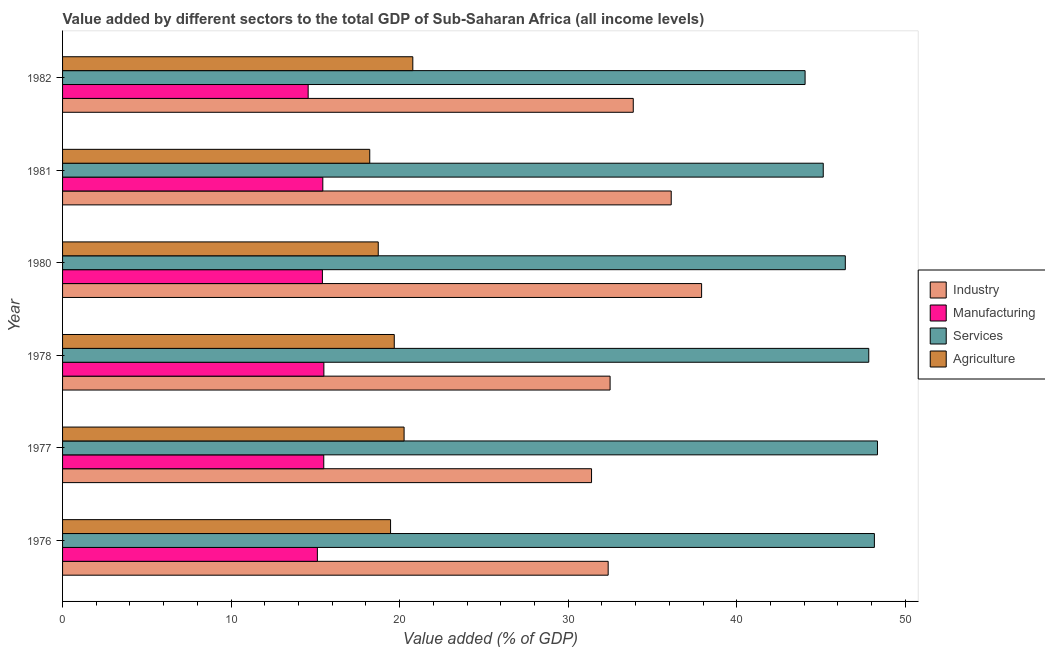How many different coloured bars are there?
Your answer should be very brief. 4. Are the number of bars per tick equal to the number of legend labels?
Keep it short and to the point. Yes. How many bars are there on the 3rd tick from the top?
Provide a succinct answer. 4. What is the label of the 6th group of bars from the top?
Your response must be concise. 1976. In how many cases, is the number of bars for a given year not equal to the number of legend labels?
Ensure brevity in your answer.  0. What is the value added by agricultural sector in 1981?
Your response must be concise. 18.23. Across all years, what is the maximum value added by manufacturing sector?
Your answer should be compact. 15.5. Across all years, what is the minimum value added by agricultural sector?
Provide a succinct answer. 18.23. In which year was the value added by services sector minimum?
Your answer should be compact. 1982. What is the total value added by services sector in the graph?
Provide a succinct answer. 279.98. What is the difference between the value added by services sector in 1981 and that in 1982?
Your response must be concise. 1.08. What is the difference between the value added by manufacturing sector in 1977 and the value added by industrial sector in 1980?
Offer a very short reply. -22.42. What is the average value added by agricultural sector per year?
Offer a terse response. 19.52. In the year 1981, what is the difference between the value added by industrial sector and value added by manufacturing sector?
Provide a succinct answer. 20.67. In how many years, is the value added by industrial sector greater than 46 %?
Ensure brevity in your answer.  0. What is the ratio of the value added by industrial sector in 1980 to that in 1981?
Provide a succinct answer. 1.05. Is the difference between the value added by industrial sector in 1980 and 1981 greater than the difference between the value added by manufacturing sector in 1980 and 1981?
Make the answer very short. Yes. What is the difference between the highest and the second highest value added by agricultural sector?
Give a very brief answer. 0.52. What is the difference between the highest and the lowest value added by industrial sector?
Make the answer very short. 6.53. In how many years, is the value added by services sector greater than the average value added by services sector taken over all years?
Provide a succinct answer. 3. Is the sum of the value added by manufacturing sector in 1978 and 1980 greater than the maximum value added by services sector across all years?
Give a very brief answer. No. Is it the case that in every year, the sum of the value added by manufacturing sector and value added by agricultural sector is greater than the sum of value added by industrial sector and value added by services sector?
Provide a short and direct response. Yes. What does the 3rd bar from the top in 1980 represents?
Provide a short and direct response. Manufacturing. What does the 2nd bar from the bottom in 1980 represents?
Make the answer very short. Manufacturing. Are all the bars in the graph horizontal?
Your answer should be very brief. Yes. How many years are there in the graph?
Keep it short and to the point. 6. Are the values on the major ticks of X-axis written in scientific E-notation?
Ensure brevity in your answer.  No. Where does the legend appear in the graph?
Your response must be concise. Center right. How many legend labels are there?
Provide a succinct answer. 4. What is the title of the graph?
Ensure brevity in your answer.  Value added by different sectors to the total GDP of Sub-Saharan Africa (all income levels). Does "UNTA" appear as one of the legend labels in the graph?
Give a very brief answer. No. What is the label or title of the X-axis?
Provide a succinct answer. Value added (% of GDP). What is the Value added (% of GDP) of Industry in 1976?
Provide a succinct answer. 32.37. What is the Value added (% of GDP) of Manufacturing in 1976?
Your answer should be very brief. 15.12. What is the Value added (% of GDP) of Services in 1976?
Make the answer very short. 48.17. What is the Value added (% of GDP) in Agriculture in 1976?
Provide a short and direct response. 19.46. What is the Value added (% of GDP) of Industry in 1977?
Give a very brief answer. 31.39. What is the Value added (% of GDP) in Manufacturing in 1977?
Ensure brevity in your answer.  15.5. What is the Value added (% of GDP) in Services in 1977?
Your answer should be very brief. 48.35. What is the Value added (% of GDP) in Agriculture in 1977?
Your answer should be compact. 20.26. What is the Value added (% of GDP) of Industry in 1978?
Ensure brevity in your answer.  32.49. What is the Value added (% of GDP) in Manufacturing in 1978?
Give a very brief answer. 15.5. What is the Value added (% of GDP) in Services in 1978?
Keep it short and to the point. 47.83. What is the Value added (% of GDP) of Agriculture in 1978?
Make the answer very short. 19.68. What is the Value added (% of GDP) in Industry in 1980?
Your answer should be very brief. 37.92. What is the Value added (% of GDP) of Manufacturing in 1980?
Your answer should be very brief. 15.42. What is the Value added (% of GDP) of Services in 1980?
Make the answer very short. 46.44. What is the Value added (% of GDP) of Agriculture in 1980?
Your answer should be compact. 18.73. What is the Value added (% of GDP) in Industry in 1981?
Provide a succinct answer. 36.11. What is the Value added (% of GDP) of Manufacturing in 1981?
Offer a terse response. 15.44. What is the Value added (% of GDP) of Services in 1981?
Provide a succinct answer. 45.13. What is the Value added (% of GDP) of Agriculture in 1981?
Give a very brief answer. 18.23. What is the Value added (% of GDP) in Industry in 1982?
Provide a short and direct response. 33.86. What is the Value added (% of GDP) in Manufacturing in 1982?
Your answer should be compact. 14.57. What is the Value added (% of GDP) in Services in 1982?
Provide a succinct answer. 44.06. What is the Value added (% of GDP) in Agriculture in 1982?
Ensure brevity in your answer.  20.78. Across all years, what is the maximum Value added (% of GDP) of Industry?
Provide a succinct answer. 37.92. Across all years, what is the maximum Value added (% of GDP) in Manufacturing?
Give a very brief answer. 15.5. Across all years, what is the maximum Value added (% of GDP) of Services?
Your response must be concise. 48.35. Across all years, what is the maximum Value added (% of GDP) of Agriculture?
Offer a very short reply. 20.78. Across all years, what is the minimum Value added (% of GDP) of Industry?
Keep it short and to the point. 31.39. Across all years, what is the minimum Value added (% of GDP) of Manufacturing?
Provide a succinct answer. 14.57. Across all years, what is the minimum Value added (% of GDP) in Services?
Give a very brief answer. 44.06. Across all years, what is the minimum Value added (% of GDP) of Agriculture?
Give a very brief answer. 18.23. What is the total Value added (% of GDP) of Industry in the graph?
Keep it short and to the point. 204.13. What is the total Value added (% of GDP) of Manufacturing in the graph?
Keep it short and to the point. 91.55. What is the total Value added (% of GDP) of Services in the graph?
Keep it short and to the point. 279.98. What is the total Value added (% of GDP) in Agriculture in the graph?
Offer a terse response. 117.14. What is the difference between the Value added (% of GDP) of Industry in 1976 and that in 1977?
Keep it short and to the point. 0.99. What is the difference between the Value added (% of GDP) in Manufacturing in 1976 and that in 1977?
Make the answer very short. -0.38. What is the difference between the Value added (% of GDP) in Services in 1976 and that in 1977?
Your answer should be very brief. -0.18. What is the difference between the Value added (% of GDP) in Agriculture in 1976 and that in 1977?
Your response must be concise. -0.8. What is the difference between the Value added (% of GDP) in Industry in 1976 and that in 1978?
Make the answer very short. -0.11. What is the difference between the Value added (% of GDP) in Manufacturing in 1976 and that in 1978?
Provide a succinct answer. -0.39. What is the difference between the Value added (% of GDP) of Services in 1976 and that in 1978?
Your response must be concise. 0.33. What is the difference between the Value added (% of GDP) of Agriculture in 1976 and that in 1978?
Provide a short and direct response. -0.22. What is the difference between the Value added (% of GDP) of Industry in 1976 and that in 1980?
Provide a short and direct response. -5.54. What is the difference between the Value added (% of GDP) in Manufacturing in 1976 and that in 1980?
Offer a very short reply. -0.3. What is the difference between the Value added (% of GDP) of Services in 1976 and that in 1980?
Make the answer very short. 1.73. What is the difference between the Value added (% of GDP) in Agriculture in 1976 and that in 1980?
Your response must be concise. 0.73. What is the difference between the Value added (% of GDP) of Industry in 1976 and that in 1981?
Your answer should be very brief. -3.74. What is the difference between the Value added (% of GDP) in Manufacturing in 1976 and that in 1981?
Offer a terse response. -0.32. What is the difference between the Value added (% of GDP) in Services in 1976 and that in 1981?
Give a very brief answer. 3.03. What is the difference between the Value added (% of GDP) of Agriculture in 1976 and that in 1981?
Keep it short and to the point. 1.23. What is the difference between the Value added (% of GDP) of Industry in 1976 and that in 1982?
Make the answer very short. -1.49. What is the difference between the Value added (% of GDP) in Manufacturing in 1976 and that in 1982?
Offer a very short reply. 0.55. What is the difference between the Value added (% of GDP) of Services in 1976 and that in 1982?
Make the answer very short. 4.11. What is the difference between the Value added (% of GDP) in Agriculture in 1976 and that in 1982?
Provide a succinct answer. -1.32. What is the difference between the Value added (% of GDP) of Industry in 1977 and that in 1978?
Provide a short and direct response. -1.1. What is the difference between the Value added (% of GDP) in Manufacturing in 1977 and that in 1978?
Provide a succinct answer. -0.01. What is the difference between the Value added (% of GDP) in Services in 1977 and that in 1978?
Provide a succinct answer. 0.52. What is the difference between the Value added (% of GDP) in Agriculture in 1977 and that in 1978?
Your answer should be very brief. 0.58. What is the difference between the Value added (% of GDP) in Industry in 1977 and that in 1980?
Your answer should be very brief. -6.53. What is the difference between the Value added (% of GDP) in Manufacturing in 1977 and that in 1980?
Give a very brief answer. 0.08. What is the difference between the Value added (% of GDP) of Services in 1977 and that in 1980?
Provide a succinct answer. 1.91. What is the difference between the Value added (% of GDP) in Agriculture in 1977 and that in 1980?
Provide a short and direct response. 1.53. What is the difference between the Value added (% of GDP) of Industry in 1977 and that in 1981?
Provide a short and direct response. -4.73. What is the difference between the Value added (% of GDP) of Manufacturing in 1977 and that in 1981?
Offer a very short reply. 0.06. What is the difference between the Value added (% of GDP) in Services in 1977 and that in 1981?
Ensure brevity in your answer.  3.22. What is the difference between the Value added (% of GDP) of Agriculture in 1977 and that in 1981?
Your response must be concise. 2.04. What is the difference between the Value added (% of GDP) in Industry in 1977 and that in 1982?
Your response must be concise. -2.47. What is the difference between the Value added (% of GDP) in Manufacturing in 1977 and that in 1982?
Keep it short and to the point. 0.93. What is the difference between the Value added (% of GDP) in Services in 1977 and that in 1982?
Offer a very short reply. 4.29. What is the difference between the Value added (% of GDP) in Agriculture in 1977 and that in 1982?
Make the answer very short. -0.52. What is the difference between the Value added (% of GDP) of Industry in 1978 and that in 1980?
Your response must be concise. -5.43. What is the difference between the Value added (% of GDP) of Manufacturing in 1978 and that in 1980?
Provide a short and direct response. 0.09. What is the difference between the Value added (% of GDP) in Services in 1978 and that in 1980?
Provide a short and direct response. 1.39. What is the difference between the Value added (% of GDP) of Agriculture in 1978 and that in 1980?
Your answer should be very brief. 0.95. What is the difference between the Value added (% of GDP) in Industry in 1978 and that in 1981?
Your response must be concise. -3.63. What is the difference between the Value added (% of GDP) in Manufacturing in 1978 and that in 1981?
Offer a very short reply. 0.06. What is the difference between the Value added (% of GDP) in Services in 1978 and that in 1981?
Your answer should be compact. 2.7. What is the difference between the Value added (% of GDP) of Agriculture in 1978 and that in 1981?
Provide a succinct answer. 1.45. What is the difference between the Value added (% of GDP) of Industry in 1978 and that in 1982?
Offer a very short reply. -1.37. What is the difference between the Value added (% of GDP) in Manufacturing in 1978 and that in 1982?
Keep it short and to the point. 0.93. What is the difference between the Value added (% of GDP) of Services in 1978 and that in 1982?
Your answer should be compact. 3.78. What is the difference between the Value added (% of GDP) of Agriculture in 1978 and that in 1982?
Offer a very short reply. -1.1. What is the difference between the Value added (% of GDP) in Industry in 1980 and that in 1981?
Ensure brevity in your answer.  1.8. What is the difference between the Value added (% of GDP) of Manufacturing in 1980 and that in 1981?
Ensure brevity in your answer.  -0.02. What is the difference between the Value added (% of GDP) of Services in 1980 and that in 1981?
Give a very brief answer. 1.31. What is the difference between the Value added (% of GDP) in Agriculture in 1980 and that in 1981?
Offer a very short reply. 0.5. What is the difference between the Value added (% of GDP) in Industry in 1980 and that in 1982?
Your answer should be compact. 4.06. What is the difference between the Value added (% of GDP) in Manufacturing in 1980 and that in 1982?
Ensure brevity in your answer.  0.84. What is the difference between the Value added (% of GDP) of Services in 1980 and that in 1982?
Offer a terse response. 2.39. What is the difference between the Value added (% of GDP) of Agriculture in 1980 and that in 1982?
Keep it short and to the point. -2.05. What is the difference between the Value added (% of GDP) of Industry in 1981 and that in 1982?
Offer a very short reply. 2.25. What is the difference between the Value added (% of GDP) of Manufacturing in 1981 and that in 1982?
Offer a terse response. 0.87. What is the difference between the Value added (% of GDP) of Services in 1981 and that in 1982?
Keep it short and to the point. 1.08. What is the difference between the Value added (% of GDP) in Agriculture in 1981 and that in 1982?
Make the answer very short. -2.56. What is the difference between the Value added (% of GDP) in Industry in 1976 and the Value added (% of GDP) in Manufacturing in 1977?
Your answer should be very brief. 16.87. What is the difference between the Value added (% of GDP) of Industry in 1976 and the Value added (% of GDP) of Services in 1977?
Give a very brief answer. -15.98. What is the difference between the Value added (% of GDP) in Industry in 1976 and the Value added (% of GDP) in Agriculture in 1977?
Your answer should be very brief. 12.11. What is the difference between the Value added (% of GDP) in Manufacturing in 1976 and the Value added (% of GDP) in Services in 1977?
Offer a terse response. -33.23. What is the difference between the Value added (% of GDP) in Manufacturing in 1976 and the Value added (% of GDP) in Agriculture in 1977?
Provide a succinct answer. -5.14. What is the difference between the Value added (% of GDP) in Services in 1976 and the Value added (% of GDP) in Agriculture in 1977?
Ensure brevity in your answer.  27.9. What is the difference between the Value added (% of GDP) in Industry in 1976 and the Value added (% of GDP) in Manufacturing in 1978?
Ensure brevity in your answer.  16.87. What is the difference between the Value added (% of GDP) of Industry in 1976 and the Value added (% of GDP) of Services in 1978?
Ensure brevity in your answer.  -15.46. What is the difference between the Value added (% of GDP) of Industry in 1976 and the Value added (% of GDP) of Agriculture in 1978?
Give a very brief answer. 12.69. What is the difference between the Value added (% of GDP) of Manufacturing in 1976 and the Value added (% of GDP) of Services in 1978?
Offer a very short reply. -32.71. What is the difference between the Value added (% of GDP) of Manufacturing in 1976 and the Value added (% of GDP) of Agriculture in 1978?
Ensure brevity in your answer.  -4.56. What is the difference between the Value added (% of GDP) of Services in 1976 and the Value added (% of GDP) of Agriculture in 1978?
Your answer should be very brief. 28.49. What is the difference between the Value added (% of GDP) of Industry in 1976 and the Value added (% of GDP) of Manufacturing in 1980?
Offer a very short reply. 16.96. What is the difference between the Value added (% of GDP) of Industry in 1976 and the Value added (% of GDP) of Services in 1980?
Keep it short and to the point. -14.07. What is the difference between the Value added (% of GDP) of Industry in 1976 and the Value added (% of GDP) of Agriculture in 1980?
Keep it short and to the point. 13.64. What is the difference between the Value added (% of GDP) of Manufacturing in 1976 and the Value added (% of GDP) of Services in 1980?
Your answer should be compact. -31.32. What is the difference between the Value added (% of GDP) of Manufacturing in 1976 and the Value added (% of GDP) of Agriculture in 1980?
Offer a very short reply. -3.61. What is the difference between the Value added (% of GDP) in Services in 1976 and the Value added (% of GDP) in Agriculture in 1980?
Your response must be concise. 29.44. What is the difference between the Value added (% of GDP) of Industry in 1976 and the Value added (% of GDP) of Manufacturing in 1981?
Give a very brief answer. 16.93. What is the difference between the Value added (% of GDP) in Industry in 1976 and the Value added (% of GDP) in Services in 1981?
Ensure brevity in your answer.  -12.76. What is the difference between the Value added (% of GDP) of Industry in 1976 and the Value added (% of GDP) of Agriculture in 1981?
Offer a very short reply. 14.15. What is the difference between the Value added (% of GDP) of Manufacturing in 1976 and the Value added (% of GDP) of Services in 1981?
Keep it short and to the point. -30.01. What is the difference between the Value added (% of GDP) of Manufacturing in 1976 and the Value added (% of GDP) of Agriculture in 1981?
Your answer should be very brief. -3.11. What is the difference between the Value added (% of GDP) in Services in 1976 and the Value added (% of GDP) in Agriculture in 1981?
Your answer should be compact. 29.94. What is the difference between the Value added (% of GDP) of Industry in 1976 and the Value added (% of GDP) of Manufacturing in 1982?
Offer a terse response. 17.8. What is the difference between the Value added (% of GDP) of Industry in 1976 and the Value added (% of GDP) of Services in 1982?
Provide a succinct answer. -11.68. What is the difference between the Value added (% of GDP) of Industry in 1976 and the Value added (% of GDP) of Agriculture in 1982?
Keep it short and to the point. 11.59. What is the difference between the Value added (% of GDP) in Manufacturing in 1976 and the Value added (% of GDP) in Services in 1982?
Offer a terse response. -28.94. What is the difference between the Value added (% of GDP) in Manufacturing in 1976 and the Value added (% of GDP) in Agriculture in 1982?
Make the answer very short. -5.66. What is the difference between the Value added (% of GDP) of Services in 1976 and the Value added (% of GDP) of Agriculture in 1982?
Keep it short and to the point. 27.39. What is the difference between the Value added (% of GDP) of Industry in 1977 and the Value added (% of GDP) of Manufacturing in 1978?
Offer a terse response. 15.88. What is the difference between the Value added (% of GDP) of Industry in 1977 and the Value added (% of GDP) of Services in 1978?
Your answer should be very brief. -16.45. What is the difference between the Value added (% of GDP) in Industry in 1977 and the Value added (% of GDP) in Agriculture in 1978?
Provide a succinct answer. 11.71. What is the difference between the Value added (% of GDP) of Manufacturing in 1977 and the Value added (% of GDP) of Services in 1978?
Make the answer very short. -32.34. What is the difference between the Value added (% of GDP) of Manufacturing in 1977 and the Value added (% of GDP) of Agriculture in 1978?
Your response must be concise. -4.18. What is the difference between the Value added (% of GDP) in Services in 1977 and the Value added (% of GDP) in Agriculture in 1978?
Keep it short and to the point. 28.67. What is the difference between the Value added (% of GDP) of Industry in 1977 and the Value added (% of GDP) of Manufacturing in 1980?
Your answer should be very brief. 15.97. What is the difference between the Value added (% of GDP) in Industry in 1977 and the Value added (% of GDP) in Services in 1980?
Provide a succinct answer. -15.06. What is the difference between the Value added (% of GDP) of Industry in 1977 and the Value added (% of GDP) of Agriculture in 1980?
Offer a very short reply. 12.66. What is the difference between the Value added (% of GDP) in Manufacturing in 1977 and the Value added (% of GDP) in Services in 1980?
Ensure brevity in your answer.  -30.94. What is the difference between the Value added (% of GDP) in Manufacturing in 1977 and the Value added (% of GDP) in Agriculture in 1980?
Offer a terse response. -3.23. What is the difference between the Value added (% of GDP) of Services in 1977 and the Value added (% of GDP) of Agriculture in 1980?
Provide a succinct answer. 29.62. What is the difference between the Value added (% of GDP) in Industry in 1977 and the Value added (% of GDP) in Manufacturing in 1981?
Your answer should be compact. 15.95. What is the difference between the Value added (% of GDP) of Industry in 1977 and the Value added (% of GDP) of Services in 1981?
Your response must be concise. -13.75. What is the difference between the Value added (% of GDP) of Industry in 1977 and the Value added (% of GDP) of Agriculture in 1981?
Ensure brevity in your answer.  13.16. What is the difference between the Value added (% of GDP) of Manufacturing in 1977 and the Value added (% of GDP) of Services in 1981?
Offer a very short reply. -29.64. What is the difference between the Value added (% of GDP) in Manufacturing in 1977 and the Value added (% of GDP) in Agriculture in 1981?
Your answer should be very brief. -2.73. What is the difference between the Value added (% of GDP) of Services in 1977 and the Value added (% of GDP) of Agriculture in 1981?
Your answer should be compact. 30.12. What is the difference between the Value added (% of GDP) in Industry in 1977 and the Value added (% of GDP) in Manufacturing in 1982?
Your answer should be compact. 16.81. What is the difference between the Value added (% of GDP) in Industry in 1977 and the Value added (% of GDP) in Services in 1982?
Offer a terse response. -12.67. What is the difference between the Value added (% of GDP) in Industry in 1977 and the Value added (% of GDP) in Agriculture in 1982?
Offer a very short reply. 10.6. What is the difference between the Value added (% of GDP) of Manufacturing in 1977 and the Value added (% of GDP) of Services in 1982?
Provide a succinct answer. -28.56. What is the difference between the Value added (% of GDP) in Manufacturing in 1977 and the Value added (% of GDP) in Agriculture in 1982?
Ensure brevity in your answer.  -5.28. What is the difference between the Value added (% of GDP) in Services in 1977 and the Value added (% of GDP) in Agriculture in 1982?
Your answer should be compact. 27.57. What is the difference between the Value added (% of GDP) of Industry in 1978 and the Value added (% of GDP) of Manufacturing in 1980?
Your answer should be compact. 17.07. What is the difference between the Value added (% of GDP) of Industry in 1978 and the Value added (% of GDP) of Services in 1980?
Make the answer very short. -13.96. What is the difference between the Value added (% of GDP) in Industry in 1978 and the Value added (% of GDP) in Agriculture in 1980?
Provide a short and direct response. 13.76. What is the difference between the Value added (% of GDP) in Manufacturing in 1978 and the Value added (% of GDP) in Services in 1980?
Make the answer very short. -30.94. What is the difference between the Value added (% of GDP) in Manufacturing in 1978 and the Value added (% of GDP) in Agriculture in 1980?
Your answer should be compact. -3.23. What is the difference between the Value added (% of GDP) in Services in 1978 and the Value added (% of GDP) in Agriculture in 1980?
Make the answer very short. 29.1. What is the difference between the Value added (% of GDP) in Industry in 1978 and the Value added (% of GDP) in Manufacturing in 1981?
Keep it short and to the point. 17.04. What is the difference between the Value added (% of GDP) in Industry in 1978 and the Value added (% of GDP) in Services in 1981?
Give a very brief answer. -12.65. What is the difference between the Value added (% of GDP) in Industry in 1978 and the Value added (% of GDP) in Agriculture in 1981?
Offer a terse response. 14.26. What is the difference between the Value added (% of GDP) in Manufacturing in 1978 and the Value added (% of GDP) in Services in 1981?
Make the answer very short. -29.63. What is the difference between the Value added (% of GDP) of Manufacturing in 1978 and the Value added (% of GDP) of Agriculture in 1981?
Provide a short and direct response. -2.72. What is the difference between the Value added (% of GDP) of Services in 1978 and the Value added (% of GDP) of Agriculture in 1981?
Your answer should be very brief. 29.61. What is the difference between the Value added (% of GDP) of Industry in 1978 and the Value added (% of GDP) of Manufacturing in 1982?
Provide a succinct answer. 17.91. What is the difference between the Value added (% of GDP) of Industry in 1978 and the Value added (% of GDP) of Services in 1982?
Your response must be concise. -11.57. What is the difference between the Value added (% of GDP) in Industry in 1978 and the Value added (% of GDP) in Agriculture in 1982?
Provide a succinct answer. 11.7. What is the difference between the Value added (% of GDP) of Manufacturing in 1978 and the Value added (% of GDP) of Services in 1982?
Provide a short and direct response. -28.55. What is the difference between the Value added (% of GDP) in Manufacturing in 1978 and the Value added (% of GDP) in Agriculture in 1982?
Provide a succinct answer. -5.28. What is the difference between the Value added (% of GDP) of Services in 1978 and the Value added (% of GDP) of Agriculture in 1982?
Offer a terse response. 27.05. What is the difference between the Value added (% of GDP) of Industry in 1980 and the Value added (% of GDP) of Manufacturing in 1981?
Your answer should be very brief. 22.47. What is the difference between the Value added (% of GDP) in Industry in 1980 and the Value added (% of GDP) in Services in 1981?
Offer a very short reply. -7.22. What is the difference between the Value added (% of GDP) of Industry in 1980 and the Value added (% of GDP) of Agriculture in 1981?
Provide a succinct answer. 19.69. What is the difference between the Value added (% of GDP) in Manufacturing in 1980 and the Value added (% of GDP) in Services in 1981?
Keep it short and to the point. -29.72. What is the difference between the Value added (% of GDP) in Manufacturing in 1980 and the Value added (% of GDP) in Agriculture in 1981?
Keep it short and to the point. -2.81. What is the difference between the Value added (% of GDP) in Services in 1980 and the Value added (% of GDP) in Agriculture in 1981?
Ensure brevity in your answer.  28.22. What is the difference between the Value added (% of GDP) in Industry in 1980 and the Value added (% of GDP) in Manufacturing in 1982?
Offer a very short reply. 23.34. What is the difference between the Value added (% of GDP) of Industry in 1980 and the Value added (% of GDP) of Services in 1982?
Offer a terse response. -6.14. What is the difference between the Value added (% of GDP) of Industry in 1980 and the Value added (% of GDP) of Agriculture in 1982?
Provide a short and direct response. 17.13. What is the difference between the Value added (% of GDP) in Manufacturing in 1980 and the Value added (% of GDP) in Services in 1982?
Provide a short and direct response. -28.64. What is the difference between the Value added (% of GDP) of Manufacturing in 1980 and the Value added (% of GDP) of Agriculture in 1982?
Provide a succinct answer. -5.36. What is the difference between the Value added (% of GDP) in Services in 1980 and the Value added (% of GDP) in Agriculture in 1982?
Ensure brevity in your answer.  25.66. What is the difference between the Value added (% of GDP) of Industry in 1981 and the Value added (% of GDP) of Manufacturing in 1982?
Make the answer very short. 21.54. What is the difference between the Value added (% of GDP) of Industry in 1981 and the Value added (% of GDP) of Services in 1982?
Your response must be concise. -7.94. What is the difference between the Value added (% of GDP) of Industry in 1981 and the Value added (% of GDP) of Agriculture in 1982?
Your answer should be very brief. 15.33. What is the difference between the Value added (% of GDP) of Manufacturing in 1981 and the Value added (% of GDP) of Services in 1982?
Your answer should be very brief. -28.61. What is the difference between the Value added (% of GDP) of Manufacturing in 1981 and the Value added (% of GDP) of Agriculture in 1982?
Provide a short and direct response. -5.34. What is the difference between the Value added (% of GDP) of Services in 1981 and the Value added (% of GDP) of Agriculture in 1982?
Give a very brief answer. 24.35. What is the average Value added (% of GDP) of Industry per year?
Offer a terse response. 34.02. What is the average Value added (% of GDP) of Manufacturing per year?
Keep it short and to the point. 15.26. What is the average Value added (% of GDP) of Services per year?
Offer a very short reply. 46.66. What is the average Value added (% of GDP) in Agriculture per year?
Provide a succinct answer. 19.52. In the year 1976, what is the difference between the Value added (% of GDP) of Industry and Value added (% of GDP) of Manufacturing?
Provide a succinct answer. 17.25. In the year 1976, what is the difference between the Value added (% of GDP) in Industry and Value added (% of GDP) in Services?
Your answer should be compact. -15.8. In the year 1976, what is the difference between the Value added (% of GDP) of Industry and Value added (% of GDP) of Agriculture?
Provide a short and direct response. 12.91. In the year 1976, what is the difference between the Value added (% of GDP) of Manufacturing and Value added (% of GDP) of Services?
Offer a terse response. -33.05. In the year 1976, what is the difference between the Value added (% of GDP) of Manufacturing and Value added (% of GDP) of Agriculture?
Provide a short and direct response. -4.34. In the year 1976, what is the difference between the Value added (% of GDP) of Services and Value added (% of GDP) of Agriculture?
Give a very brief answer. 28.71. In the year 1977, what is the difference between the Value added (% of GDP) of Industry and Value added (% of GDP) of Manufacturing?
Ensure brevity in your answer.  15.89. In the year 1977, what is the difference between the Value added (% of GDP) in Industry and Value added (% of GDP) in Services?
Make the answer very short. -16.96. In the year 1977, what is the difference between the Value added (% of GDP) in Industry and Value added (% of GDP) in Agriculture?
Your response must be concise. 11.12. In the year 1977, what is the difference between the Value added (% of GDP) of Manufacturing and Value added (% of GDP) of Services?
Your answer should be compact. -32.85. In the year 1977, what is the difference between the Value added (% of GDP) of Manufacturing and Value added (% of GDP) of Agriculture?
Keep it short and to the point. -4.77. In the year 1977, what is the difference between the Value added (% of GDP) of Services and Value added (% of GDP) of Agriculture?
Provide a short and direct response. 28.09. In the year 1978, what is the difference between the Value added (% of GDP) of Industry and Value added (% of GDP) of Manufacturing?
Offer a terse response. 16.98. In the year 1978, what is the difference between the Value added (% of GDP) of Industry and Value added (% of GDP) of Services?
Your answer should be very brief. -15.35. In the year 1978, what is the difference between the Value added (% of GDP) in Industry and Value added (% of GDP) in Agriculture?
Offer a terse response. 12.8. In the year 1978, what is the difference between the Value added (% of GDP) of Manufacturing and Value added (% of GDP) of Services?
Ensure brevity in your answer.  -32.33. In the year 1978, what is the difference between the Value added (% of GDP) of Manufacturing and Value added (% of GDP) of Agriculture?
Your response must be concise. -4.18. In the year 1978, what is the difference between the Value added (% of GDP) of Services and Value added (% of GDP) of Agriculture?
Your answer should be very brief. 28.15. In the year 1980, what is the difference between the Value added (% of GDP) of Industry and Value added (% of GDP) of Manufacturing?
Your answer should be very brief. 22.5. In the year 1980, what is the difference between the Value added (% of GDP) of Industry and Value added (% of GDP) of Services?
Your answer should be compact. -8.53. In the year 1980, what is the difference between the Value added (% of GDP) in Industry and Value added (% of GDP) in Agriculture?
Ensure brevity in your answer.  19.19. In the year 1980, what is the difference between the Value added (% of GDP) of Manufacturing and Value added (% of GDP) of Services?
Your answer should be very brief. -31.03. In the year 1980, what is the difference between the Value added (% of GDP) in Manufacturing and Value added (% of GDP) in Agriculture?
Make the answer very short. -3.31. In the year 1980, what is the difference between the Value added (% of GDP) in Services and Value added (% of GDP) in Agriculture?
Provide a succinct answer. 27.71. In the year 1981, what is the difference between the Value added (% of GDP) of Industry and Value added (% of GDP) of Manufacturing?
Ensure brevity in your answer.  20.67. In the year 1981, what is the difference between the Value added (% of GDP) of Industry and Value added (% of GDP) of Services?
Provide a short and direct response. -9.02. In the year 1981, what is the difference between the Value added (% of GDP) of Industry and Value added (% of GDP) of Agriculture?
Your answer should be very brief. 17.89. In the year 1981, what is the difference between the Value added (% of GDP) of Manufacturing and Value added (% of GDP) of Services?
Keep it short and to the point. -29.69. In the year 1981, what is the difference between the Value added (% of GDP) in Manufacturing and Value added (% of GDP) in Agriculture?
Provide a succinct answer. -2.79. In the year 1981, what is the difference between the Value added (% of GDP) of Services and Value added (% of GDP) of Agriculture?
Offer a very short reply. 26.91. In the year 1982, what is the difference between the Value added (% of GDP) of Industry and Value added (% of GDP) of Manufacturing?
Provide a short and direct response. 19.29. In the year 1982, what is the difference between the Value added (% of GDP) in Industry and Value added (% of GDP) in Services?
Keep it short and to the point. -10.2. In the year 1982, what is the difference between the Value added (% of GDP) of Industry and Value added (% of GDP) of Agriculture?
Offer a terse response. 13.08. In the year 1982, what is the difference between the Value added (% of GDP) in Manufacturing and Value added (% of GDP) in Services?
Give a very brief answer. -29.48. In the year 1982, what is the difference between the Value added (% of GDP) of Manufacturing and Value added (% of GDP) of Agriculture?
Ensure brevity in your answer.  -6.21. In the year 1982, what is the difference between the Value added (% of GDP) of Services and Value added (% of GDP) of Agriculture?
Provide a short and direct response. 23.27. What is the ratio of the Value added (% of GDP) in Industry in 1976 to that in 1977?
Your answer should be compact. 1.03. What is the ratio of the Value added (% of GDP) of Manufacturing in 1976 to that in 1977?
Offer a very short reply. 0.98. What is the ratio of the Value added (% of GDP) in Agriculture in 1976 to that in 1977?
Provide a short and direct response. 0.96. What is the ratio of the Value added (% of GDP) in Industry in 1976 to that in 1978?
Make the answer very short. 1. What is the ratio of the Value added (% of GDP) of Manufacturing in 1976 to that in 1978?
Offer a very short reply. 0.98. What is the ratio of the Value added (% of GDP) of Industry in 1976 to that in 1980?
Give a very brief answer. 0.85. What is the ratio of the Value added (% of GDP) in Manufacturing in 1976 to that in 1980?
Provide a succinct answer. 0.98. What is the ratio of the Value added (% of GDP) in Services in 1976 to that in 1980?
Offer a very short reply. 1.04. What is the ratio of the Value added (% of GDP) in Agriculture in 1976 to that in 1980?
Offer a terse response. 1.04. What is the ratio of the Value added (% of GDP) of Industry in 1976 to that in 1981?
Make the answer very short. 0.9. What is the ratio of the Value added (% of GDP) of Manufacturing in 1976 to that in 1981?
Give a very brief answer. 0.98. What is the ratio of the Value added (% of GDP) of Services in 1976 to that in 1981?
Offer a terse response. 1.07. What is the ratio of the Value added (% of GDP) of Agriculture in 1976 to that in 1981?
Your response must be concise. 1.07. What is the ratio of the Value added (% of GDP) in Industry in 1976 to that in 1982?
Provide a succinct answer. 0.96. What is the ratio of the Value added (% of GDP) of Manufacturing in 1976 to that in 1982?
Your response must be concise. 1.04. What is the ratio of the Value added (% of GDP) in Services in 1976 to that in 1982?
Your answer should be compact. 1.09. What is the ratio of the Value added (% of GDP) of Agriculture in 1976 to that in 1982?
Ensure brevity in your answer.  0.94. What is the ratio of the Value added (% of GDP) of Industry in 1977 to that in 1978?
Offer a very short reply. 0.97. What is the ratio of the Value added (% of GDP) in Manufacturing in 1977 to that in 1978?
Offer a terse response. 1. What is the ratio of the Value added (% of GDP) in Services in 1977 to that in 1978?
Your response must be concise. 1.01. What is the ratio of the Value added (% of GDP) of Agriculture in 1977 to that in 1978?
Provide a short and direct response. 1.03. What is the ratio of the Value added (% of GDP) in Industry in 1977 to that in 1980?
Offer a terse response. 0.83. What is the ratio of the Value added (% of GDP) in Services in 1977 to that in 1980?
Ensure brevity in your answer.  1.04. What is the ratio of the Value added (% of GDP) in Agriculture in 1977 to that in 1980?
Offer a very short reply. 1.08. What is the ratio of the Value added (% of GDP) of Industry in 1977 to that in 1981?
Provide a succinct answer. 0.87. What is the ratio of the Value added (% of GDP) in Services in 1977 to that in 1981?
Provide a short and direct response. 1.07. What is the ratio of the Value added (% of GDP) in Agriculture in 1977 to that in 1981?
Your answer should be very brief. 1.11. What is the ratio of the Value added (% of GDP) of Industry in 1977 to that in 1982?
Give a very brief answer. 0.93. What is the ratio of the Value added (% of GDP) in Manufacturing in 1977 to that in 1982?
Ensure brevity in your answer.  1.06. What is the ratio of the Value added (% of GDP) in Services in 1977 to that in 1982?
Offer a very short reply. 1.1. What is the ratio of the Value added (% of GDP) of Agriculture in 1977 to that in 1982?
Give a very brief answer. 0.98. What is the ratio of the Value added (% of GDP) of Industry in 1978 to that in 1980?
Provide a succinct answer. 0.86. What is the ratio of the Value added (% of GDP) in Manufacturing in 1978 to that in 1980?
Your answer should be compact. 1.01. What is the ratio of the Value added (% of GDP) of Agriculture in 1978 to that in 1980?
Give a very brief answer. 1.05. What is the ratio of the Value added (% of GDP) in Industry in 1978 to that in 1981?
Provide a short and direct response. 0.9. What is the ratio of the Value added (% of GDP) in Services in 1978 to that in 1981?
Your answer should be compact. 1.06. What is the ratio of the Value added (% of GDP) in Agriculture in 1978 to that in 1981?
Provide a short and direct response. 1.08. What is the ratio of the Value added (% of GDP) in Industry in 1978 to that in 1982?
Provide a succinct answer. 0.96. What is the ratio of the Value added (% of GDP) of Manufacturing in 1978 to that in 1982?
Ensure brevity in your answer.  1.06. What is the ratio of the Value added (% of GDP) of Services in 1978 to that in 1982?
Your answer should be compact. 1.09. What is the ratio of the Value added (% of GDP) in Agriculture in 1978 to that in 1982?
Offer a terse response. 0.95. What is the ratio of the Value added (% of GDP) of Industry in 1980 to that in 1981?
Make the answer very short. 1.05. What is the ratio of the Value added (% of GDP) in Agriculture in 1980 to that in 1981?
Ensure brevity in your answer.  1.03. What is the ratio of the Value added (% of GDP) of Industry in 1980 to that in 1982?
Your answer should be compact. 1.12. What is the ratio of the Value added (% of GDP) in Manufacturing in 1980 to that in 1982?
Give a very brief answer. 1.06. What is the ratio of the Value added (% of GDP) in Services in 1980 to that in 1982?
Ensure brevity in your answer.  1.05. What is the ratio of the Value added (% of GDP) in Agriculture in 1980 to that in 1982?
Your answer should be compact. 0.9. What is the ratio of the Value added (% of GDP) in Industry in 1981 to that in 1982?
Offer a terse response. 1.07. What is the ratio of the Value added (% of GDP) in Manufacturing in 1981 to that in 1982?
Your answer should be compact. 1.06. What is the ratio of the Value added (% of GDP) of Services in 1981 to that in 1982?
Ensure brevity in your answer.  1.02. What is the ratio of the Value added (% of GDP) in Agriculture in 1981 to that in 1982?
Your answer should be compact. 0.88. What is the difference between the highest and the second highest Value added (% of GDP) in Industry?
Ensure brevity in your answer.  1.8. What is the difference between the highest and the second highest Value added (% of GDP) of Manufacturing?
Your answer should be compact. 0.01. What is the difference between the highest and the second highest Value added (% of GDP) in Services?
Provide a short and direct response. 0.18. What is the difference between the highest and the second highest Value added (% of GDP) of Agriculture?
Provide a succinct answer. 0.52. What is the difference between the highest and the lowest Value added (% of GDP) in Industry?
Provide a short and direct response. 6.53. What is the difference between the highest and the lowest Value added (% of GDP) in Manufacturing?
Give a very brief answer. 0.93. What is the difference between the highest and the lowest Value added (% of GDP) of Services?
Give a very brief answer. 4.29. What is the difference between the highest and the lowest Value added (% of GDP) of Agriculture?
Offer a terse response. 2.56. 